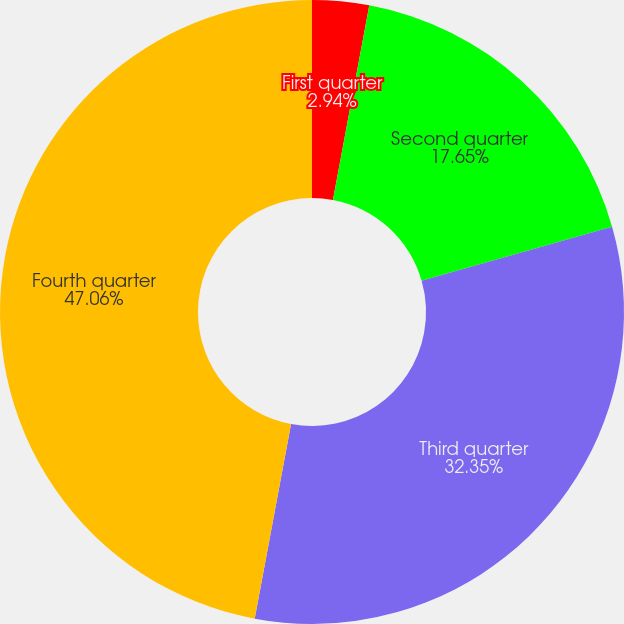Convert chart to OTSL. <chart><loc_0><loc_0><loc_500><loc_500><pie_chart><fcel>First quarter<fcel>Second quarter<fcel>Third quarter<fcel>Fourth quarter<nl><fcel>2.94%<fcel>17.65%<fcel>32.35%<fcel>47.06%<nl></chart> 